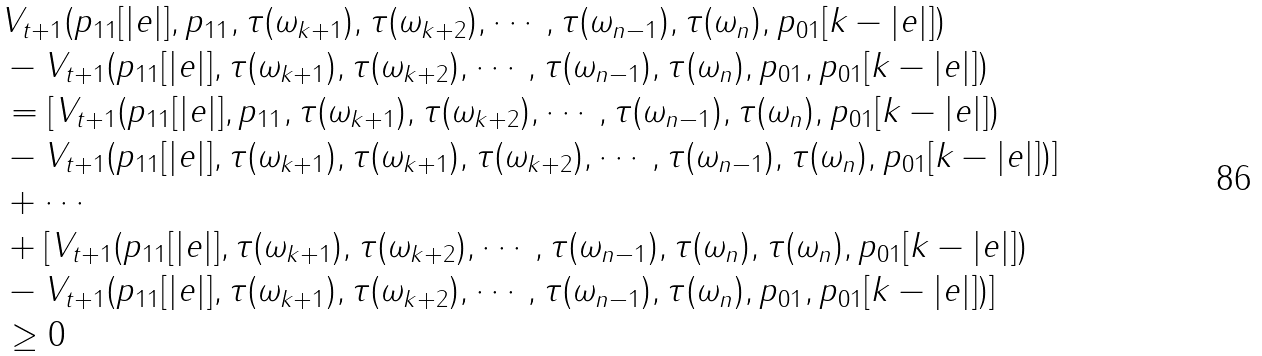Convert formula to latex. <formula><loc_0><loc_0><loc_500><loc_500>& V _ { t + 1 } ( p _ { 1 1 } [ | e | ] , p _ { 1 1 } , \tau ( { \omega _ { k + 1 } } ) , \tau ( { \omega _ { k + 2 } } ) , \cdots , \tau ( { \omega _ { n - 1 } } ) , \tau ( { \omega _ { n } } ) , p _ { 0 1 } [ k - | e | ] ) \\ & - V _ { t + 1 } ( p _ { 1 1 } [ | e | ] , \tau ( { \omega _ { k + 1 } } ) , \tau ( { \omega _ { k + 2 } } ) , \cdots , \tau ( { \omega _ { n - 1 } } ) , \tau ( { \omega _ { n } } ) , p _ { 0 1 } , p _ { 0 1 } [ k - | e | ] ) \\ & = [ V _ { t + 1 } ( p _ { 1 1 } [ | e | ] , p _ { 1 1 } , \tau ( { \omega _ { k + 1 } } ) , \tau ( { \omega _ { k + 2 } } ) , \cdots , \tau ( { \omega _ { n - 1 } } ) , \tau ( { \omega _ { n } } ) , p _ { 0 1 } [ k - | e | ] ) \\ & - V _ { t + 1 } ( p _ { 1 1 } [ | e | ] , \tau ( { \omega _ { k + 1 } } ) , \tau ( { \omega _ { k + 1 } } ) , \tau ( { \omega _ { k + 2 } } ) , \cdots , \tau ( { \omega _ { n - 1 } } ) , \tau ( { \omega _ { n } } ) , p _ { 0 1 } [ k - | e | ] ) ] \\ & + \cdots \\ & + [ V _ { t + 1 } ( p _ { 1 1 } [ | e | ] , \tau ( { \omega _ { k + 1 } } ) , \tau ( { \omega _ { k + 2 } } ) , \cdots , \tau ( { \omega _ { n - 1 } } ) , \tau ( { \omega _ { n } } ) , \tau ( { \omega _ { n } } ) , p _ { 0 1 } [ k - | e | ] ) \\ & - V _ { t + 1 } ( p _ { 1 1 } [ | e | ] , \tau ( { \omega _ { k + 1 } } ) , \tau ( { \omega _ { k + 2 } } ) , \cdots , \tau ( { \omega _ { n - 1 } } ) , \tau ( { \omega _ { n } } ) , p _ { 0 1 } , p _ { 0 1 } [ k - | e | ] ) ] \\ & \geq 0</formula> 